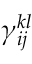Convert formula to latex. <formula><loc_0><loc_0><loc_500><loc_500>{ \gamma } _ { i j } ^ { k l }</formula> 